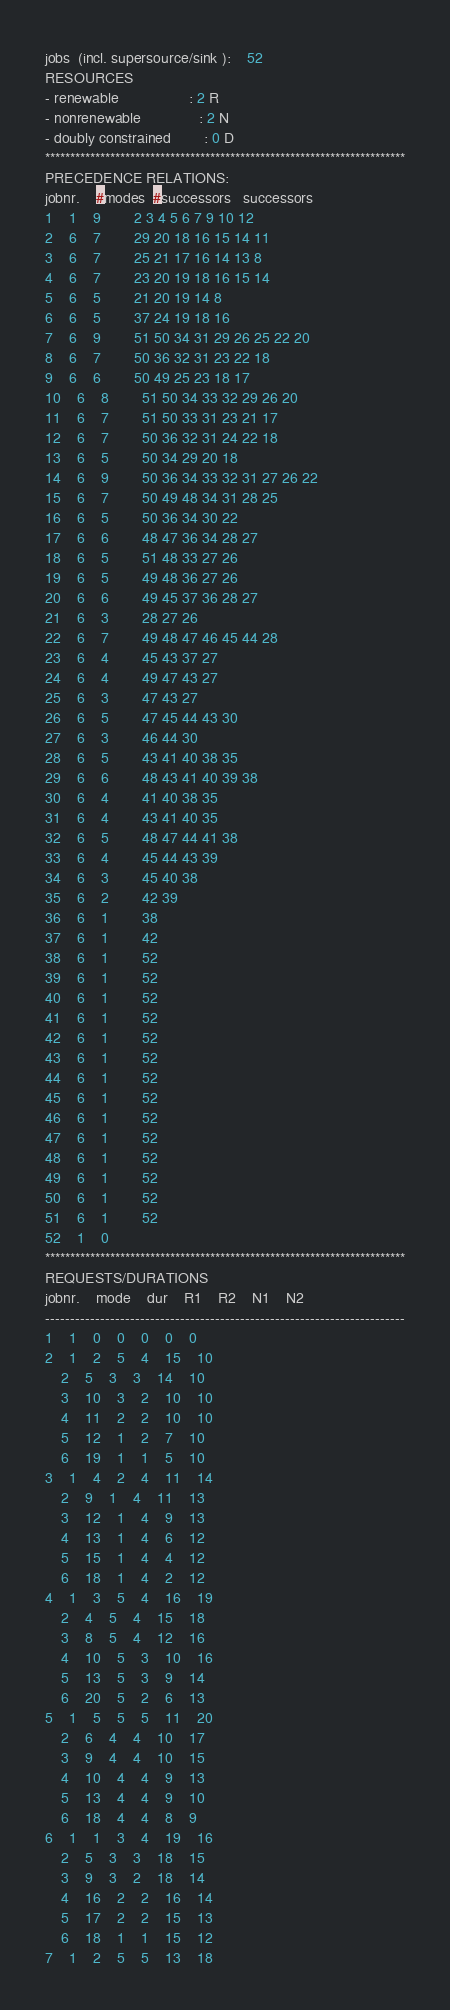Convert code to text. <code><loc_0><loc_0><loc_500><loc_500><_ObjectiveC_>jobs  (incl. supersource/sink ):	52
RESOURCES
- renewable                 : 2 R
- nonrenewable              : 2 N
- doubly constrained        : 0 D
************************************************************************
PRECEDENCE RELATIONS:
jobnr.    #modes  #successors   successors
1	1	9		2 3 4 5 6 7 9 10 12 
2	6	7		29 20 18 16 15 14 11 
3	6	7		25 21 17 16 14 13 8 
4	6	7		23 20 19 18 16 15 14 
5	6	5		21 20 19 14 8 
6	6	5		37 24 19 18 16 
7	6	9		51 50 34 31 29 26 25 22 20 
8	6	7		50 36 32 31 23 22 18 
9	6	6		50 49 25 23 18 17 
10	6	8		51 50 34 33 32 29 26 20 
11	6	7		51 50 33 31 23 21 17 
12	6	7		50 36 32 31 24 22 18 
13	6	5		50 34 29 20 18 
14	6	9		50 36 34 33 32 31 27 26 22 
15	6	7		50 49 48 34 31 28 25 
16	6	5		50 36 34 30 22 
17	6	6		48 47 36 34 28 27 
18	6	5		51 48 33 27 26 
19	6	5		49 48 36 27 26 
20	6	6		49 45 37 36 28 27 
21	6	3		28 27 26 
22	6	7		49 48 47 46 45 44 28 
23	6	4		45 43 37 27 
24	6	4		49 47 43 27 
25	6	3		47 43 27 
26	6	5		47 45 44 43 30 
27	6	3		46 44 30 
28	6	5		43 41 40 38 35 
29	6	6		48 43 41 40 39 38 
30	6	4		41 40 38 35 
31	6	4		43 41 40 35 
32	6	5		48 47 44 41 38 
33	6	4		45 44 43 39 
34	6	3		45 40 38 
35	6	2		42 39 
36	6	1		38 
37	6	1		42 
38	6	1		52 
39	6	1		52 
40	6	1		52 
41	6	1		52 
42	6	1		52 
43	6	1		52 
44	6	1		52 
45	6	1		52 
46	6	1		52 
47	6	1		52 
48	6	1		52 
49	6	1		52 
50	6	1		52 
51	6	1		52 
52	1	0		
************************************************************************
REQUESTS/DURATIONS
jobnr.	mode	dur	R1	R2	N1	N2	
------------------------------------------------------------------------
1	1	0	0	0	0	0	
2	1	2	5	4	15	10	
	2	5	3	3	14	10	
	3	10	3	2	10	10	
	4	11	2	2	10	10	
	5	12	1	2	7	10	
	6	19	1	1	5	10	
3	1	4	2	4	11	14	
	2	9	1	4	11	13	
	3	12	1	4	9	13	
	4	13	1	4	6	12	
	5	15	1	4	4	12	
	6	18	1	4	2	12	
4	1	3	5	4	16	19	
	2	4	5	4	15	18	
	3	8	5	4	12	16	
	4	10	5	3	10	16	
	5	13	5	3	9	14	
	6	20	5	2	6	13	
5	1	5	5	5	11	20	
	2	6	4	4	10	17	
	3	9	4	4	10	15	
	4	10	4	4	9	13	
	5	13	4	4	9	10	
	6	18	4	4	8	9	
6	1	1	3	4	19	16	
	2	5	3	3	18	15	
	3	9	3	2	18	14	
	4	16	2	2	16	14	
	5	17	2	2	15	13	
	6	18	1	1	15	12	
7	1	2	5	5	13	18	</code> 